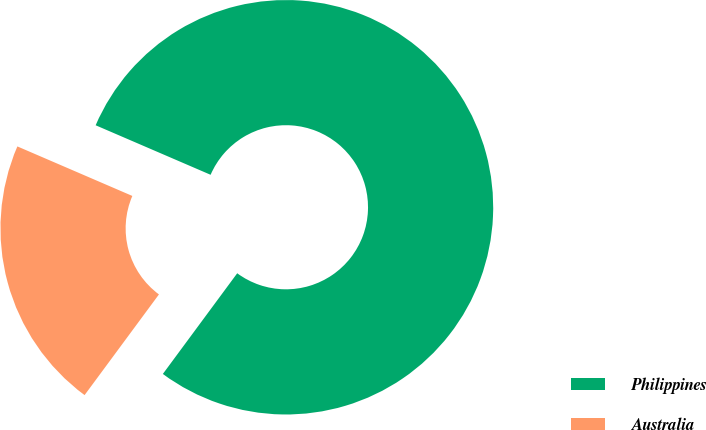Convert chart to OTSL. <chart><loc_0><loc_0><loc_500><loc_500><pie_chart><fcel>Philippines<fcel>Australia<nl><fcel>78.65%<fcel>21.35%<nl></chart> 